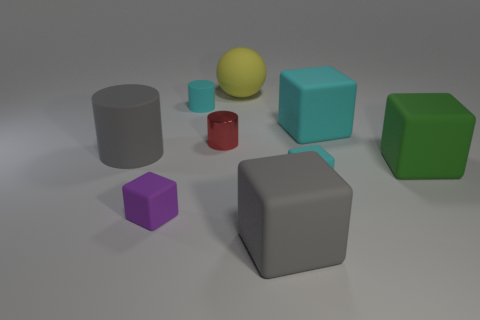Can you describe the size and color of the object located at the very center of the image? Certainly, at the center of the image is a medium-sized yellow sphere. Its surface appears to be matte, and it contrasts with the other geometric objects around it. 